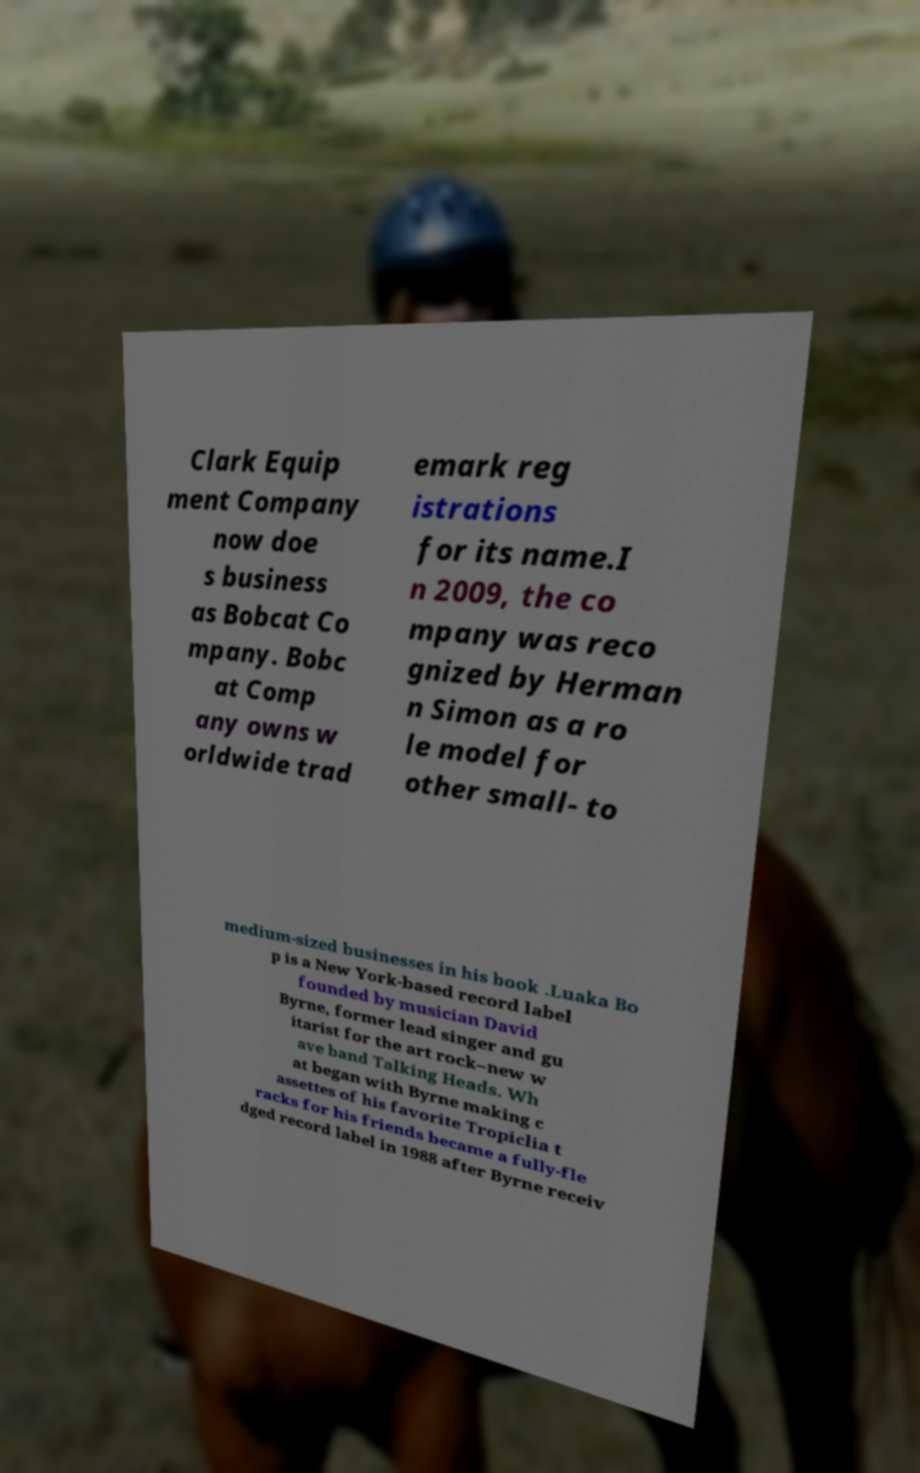There's text embedded in this image that I need extracted. Can you transcribe it verbatim? Clark Equip ment Company now doe s business as Bobcat Co mpany. Bobc at Comp any owns w orldwide trad emark reg istrations for its name.I n 2009, the co mpany was reco gnized by Herman n Simon as a ro le model for other small- to medium-sized businesses in his book .Luaka Bo p is a New York-based record label founded by musician David Byrne, former lead singer and gu itarist for the art rock–new w ave band Talking Heads. Wh at began with Byrne making c assettes of his favorite Tropiclia t racks for his friends became a fully-fle dged record label in 1988 after Byrne receiv 